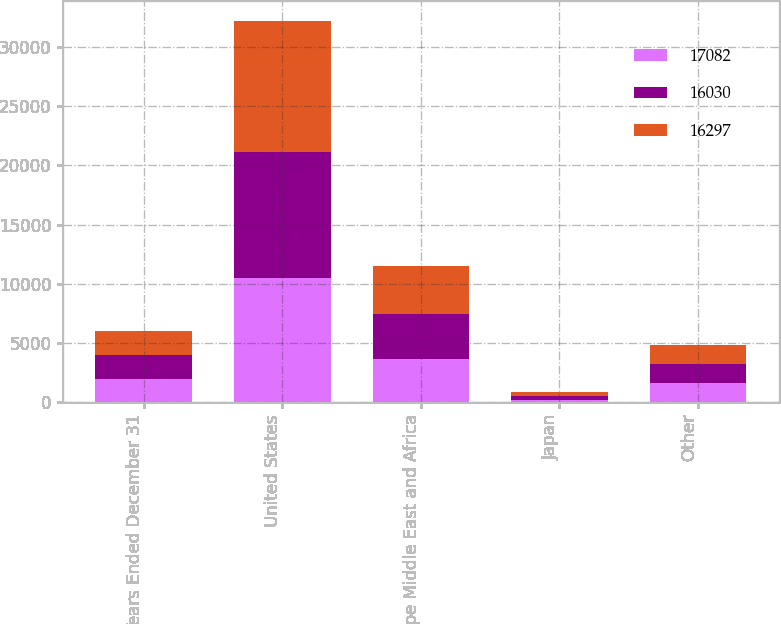Convert chart to OTSL. <chart><loc_0><loc_0><loc_500><loc_500><stacked_bar_chart><ecel><fcel>Years Ended December 31<fcel>United States<fcel>Europe Middle East and Africa<fcel>Japan<fcel>Other<nl><fcel>17082<fcel>2012<fcel>10490<fcel>3688<fcel>243<fcel>1609<nl><fcel>16030<fcel>2011<fcel>10646<fcel>3780<fcel>279<fcel>1592<nl><fcel>16297<fcel>2010<fcel>11078<fcel>4014<fcel>315<fcel>1675<nl></chart> 